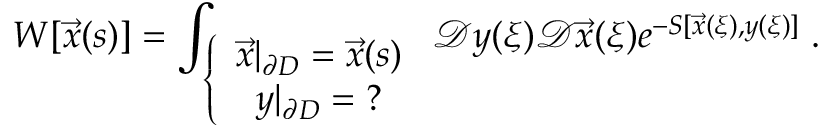<formula> <loc_0><loc_0><loc_500><loc_500>W [ \vec { x } ( s ) ] = \int _ { \left \{ \begin{array} { c } { { \vec { x } | _ { \partial D } = \vec { x } ( s ) } } \\ { { y | _ { \partial D } = ? } } \end{array} } \mathcal { D } y ( \xi ) \mathcal { D } \vec { x } ( \xi ) e ^ { - S [ \vec { x } ( \xi ) , y ( \xi ) ] } \, .</formula> 